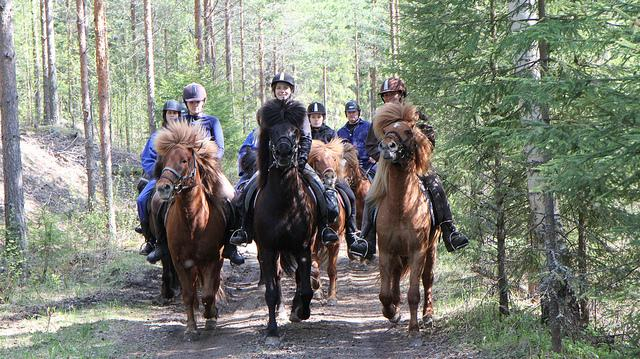What is unusually long here? Please explain your reasoning. manes. The manes are very bushy. 